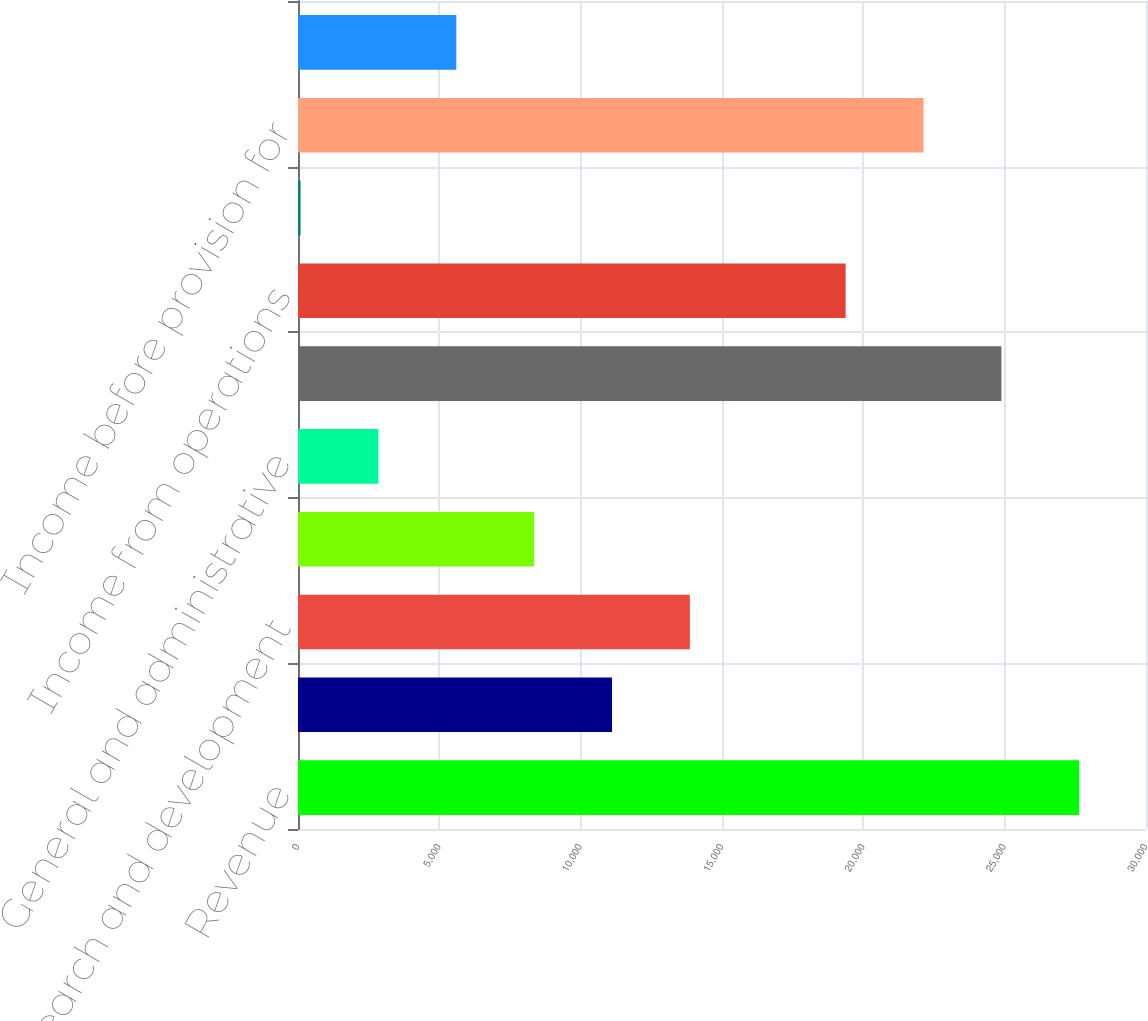Convert chart. <chart><loc_0><loc_0><loc_500><loc_500><bar_chart><fcel>Revenue<fcel>Cost of revenue<fcel>Research and development<fcel>Marketing and sales<fcel>General and administrative<fcel>Total costs and expenses<fcel>Income from operations<fcel>Interest and other<fcel>Income before provision for<fcel>Provision for income taxes<nl><fcel>27638<fcel>11109.8<fcel>13864.5<fcel>8355.1<fcel>2845.7<fcel>24883.3<fcel>19373.9<fcel>91<fcel>22128.6<fcel>5600.4<nl></chart> 